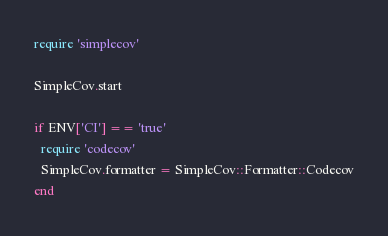Convert code to text. <code><loc_0><loc_0><loc_500><loc_500><_Ruby_>require 'simplecov'

SimpleCov.start

if ENV['CI'] == 'true'
  require 'codecov'
  SimpleCov.formatter = SimpleCov::Formatter::Codecov
end
</code> 